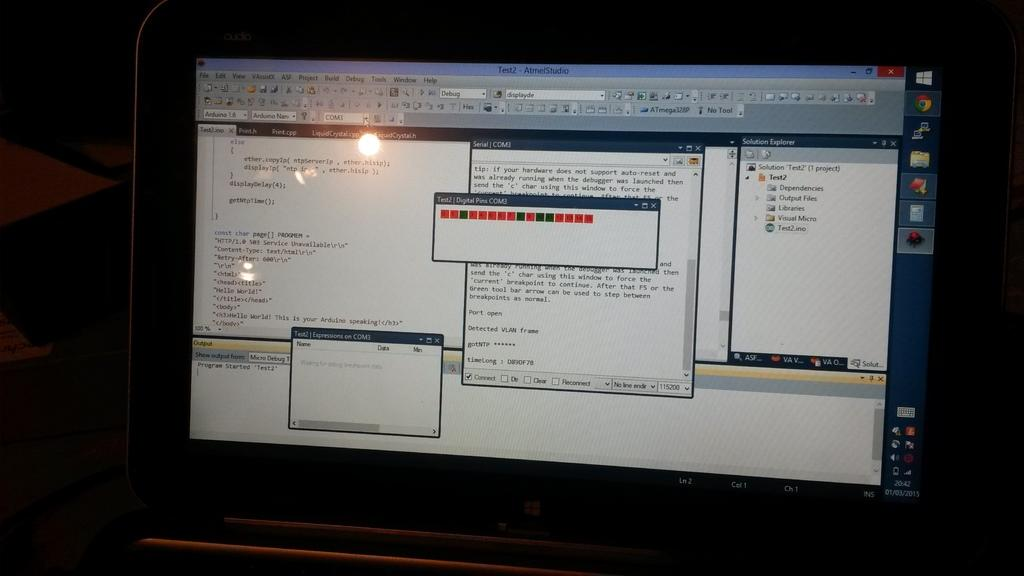<image>
Render a clear and concise summary of the photo. a computer screen with a tab open titled 'test2 - atmelstudio 